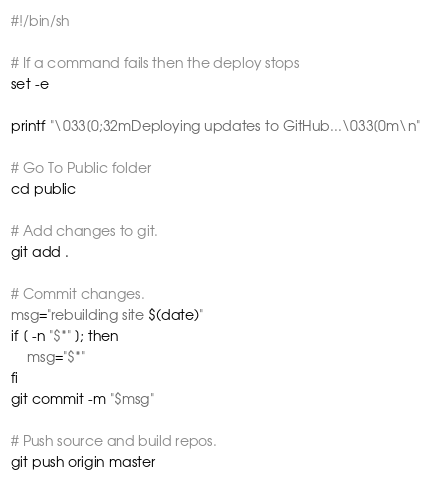<code> <loc_0><loc_0><loc_500><loc_500><_Bash_>#!/bin/sh

# If a command fails then the deploy stops
set -e

printf "\033[0;32mDeploying updates to GitHub...\033[0m\n"

# Go To Public folder
cd public

# Add changes to git.
git add .

# Commit changes.
msg="rebuilding site $(date)"
if [ -n "$*" ]; then
	msg="$*"
fi
git commit -m "$msg"

# Push source and build repos.
git push origin master
</code> 